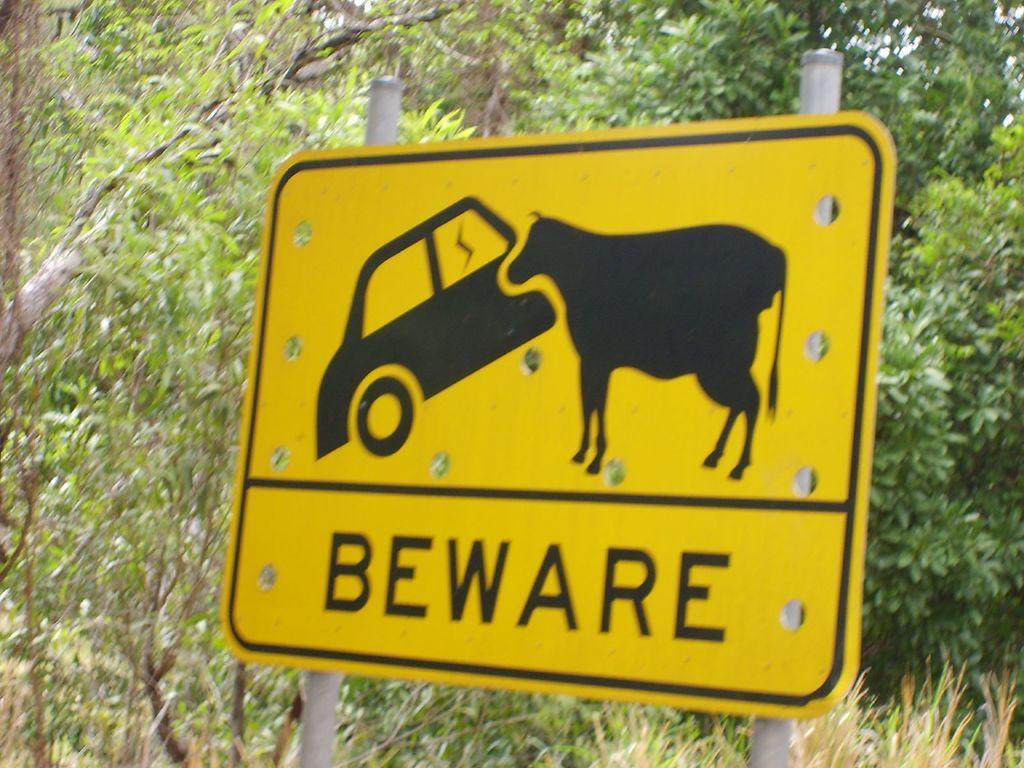How would you summarize this image in a sentence or two? In this image we can see a yellow color sign board. Behind the board so many trees are present. 